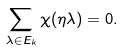Convert formula to latex. <formula><loc_0><loc_0><loc_500><loc_500>\sum _ { \lambda \in E _ { k } } { \chi ( \eta \lambda ) } = 0 .</formula> 